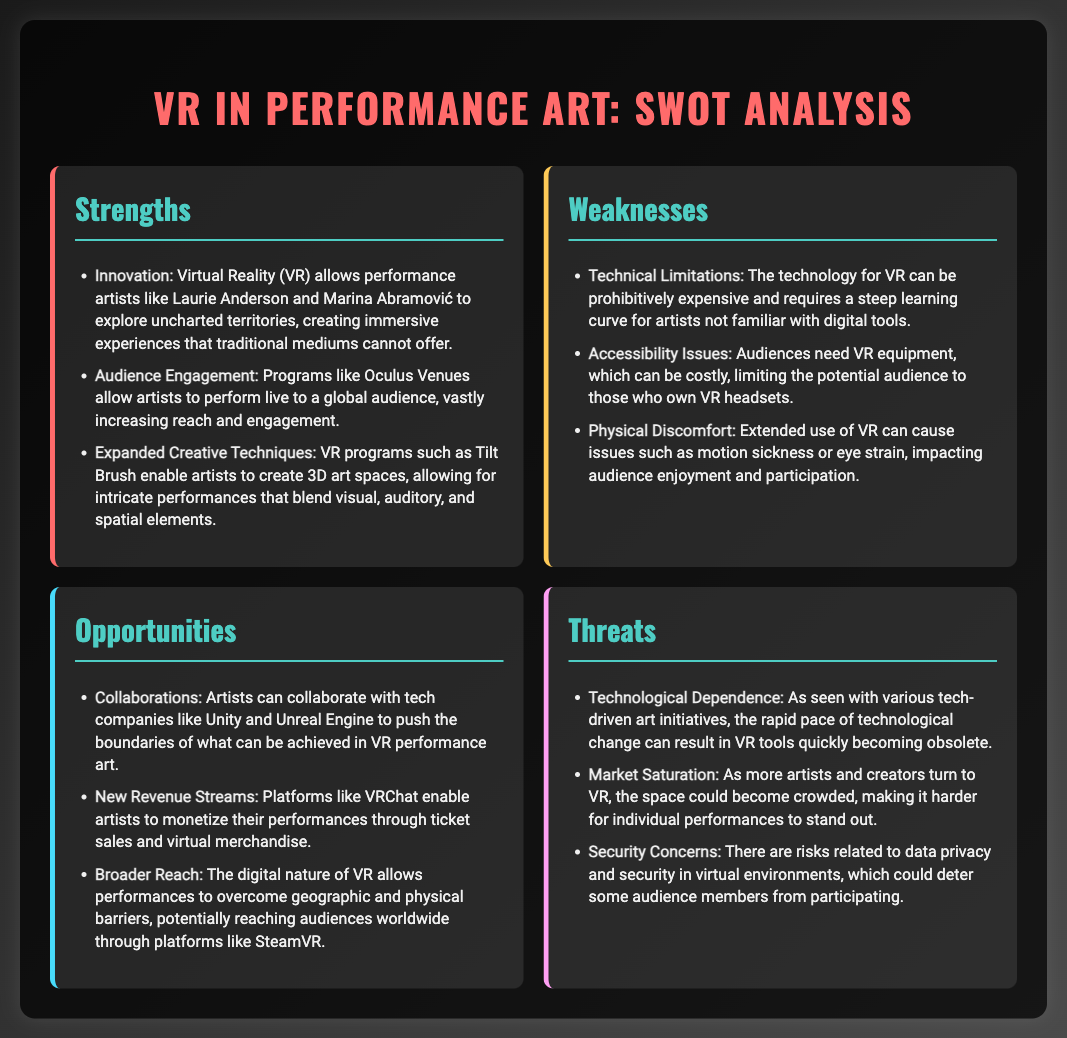what is one strength mentioned for VR in performance art? The document lists "Innovation" as a strength, highlighting the potential of VR to create immersive experiences.
Answer: Innovation what is one weakness related to audience accessibility? The document states that the cost of VR equipment can limit the potential audience.
Answer: Accessibility Issues name one opportunity for performance artists integrating VR technology. The document mentions "Collaborations" as an opportunity for artists to work with tech companies to enhance VR performance art.
Answer: Collaborations how many strengths are listed in the SWOT analysis? There are three strengths enumerated in the document.
Answer: 3 what is a potential threat mentioned about the VR tools? The document notes "Technological Dependence" as a concern regarding the rapid change in technology.
Answer: Technological Dependence list one example of a platform mentioned for monetizing VR performances. The SWOT analysis refers to "VRChat" as a platform that enables artists to monetize performances.
Answer: VRChat what unique aspect of VR performances allows for a broader reach? The document indicates that the "digital nature" of VR allows for performances to overcome geographic barriers.
Answer: Broader Reach which artist is mentioned as an example of innovation in VR performance art? The document references "Laurie Anderson" as an artist exploring uncharted territories in VR.
Answer: Laurie Anderson what is a potential issue audiences may experience with VR technology? The document mentions "motion sickness" as a physical discomfort that can occur with extended VR use.
Answer: Motion sickness 